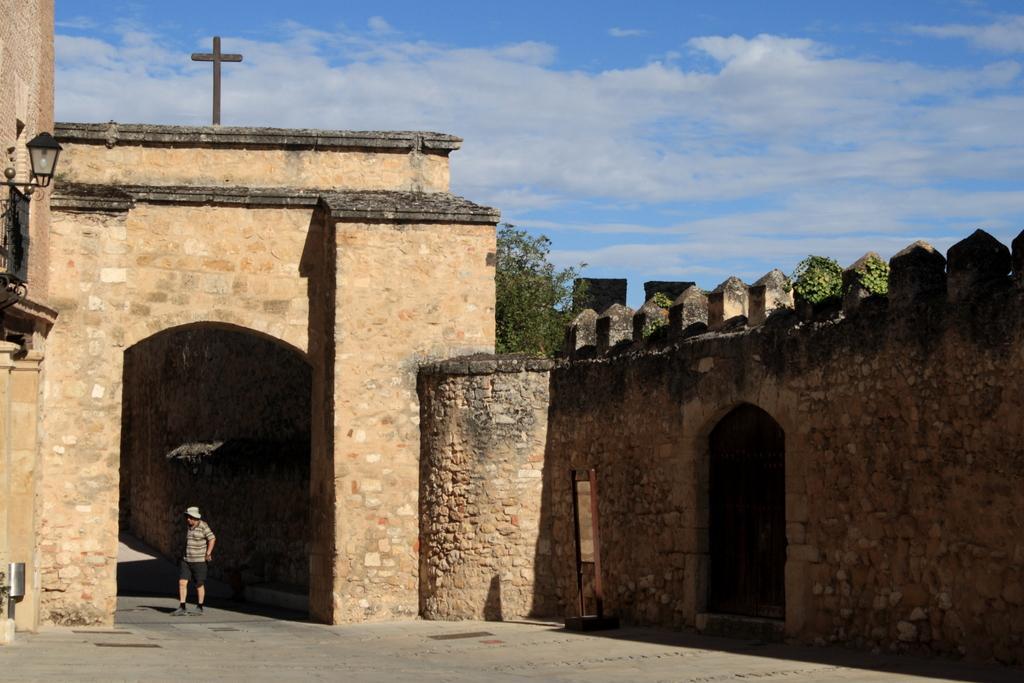Could you give a brief overview of what you see in this image? In the picture there is a fort and above the fort there is a Christ cross, under the roof of the fort there is a man. 